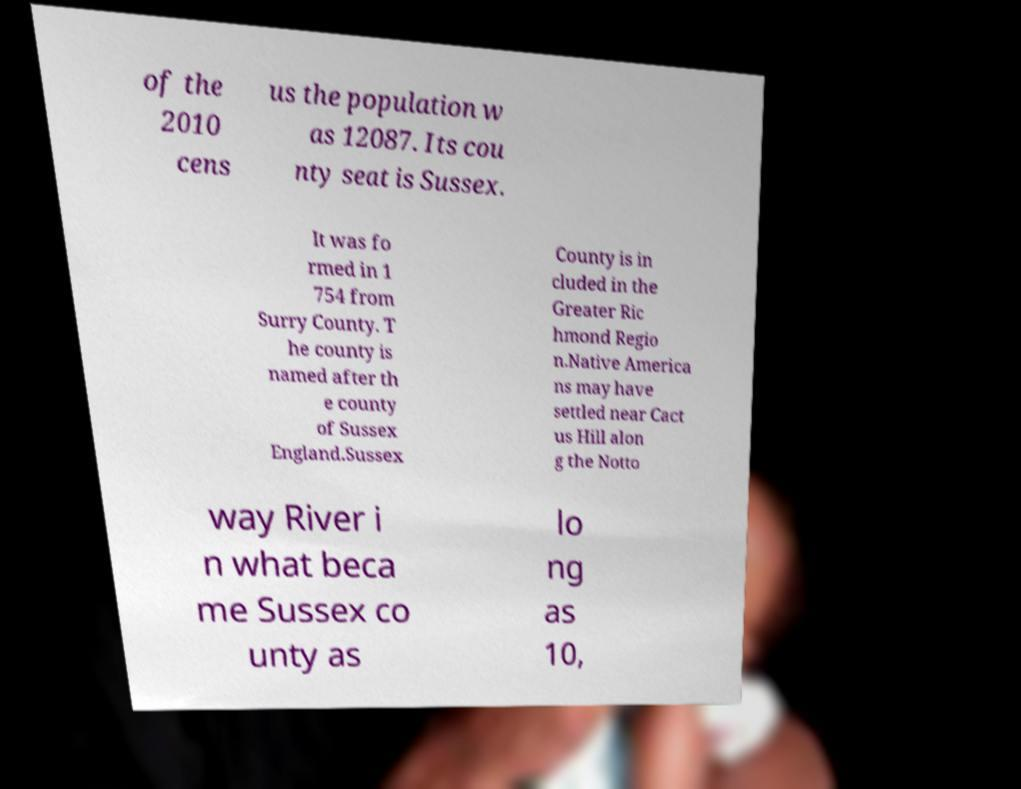Can you accurately transcribe the text from the provided image for me? of the 2010 cens us the population w as 12087. Its cou nty seat is Sussex. It was fo rmed in 1 754 from Surry County. T he county is named after th e county of Sussex England.Sussex County is in cluded in the Greater Ric hmond Regio n.Native America ns may have settled near Cact us Hill alon g the Notto way River i n what beca me Sussex co unty as lo ng as 10, 